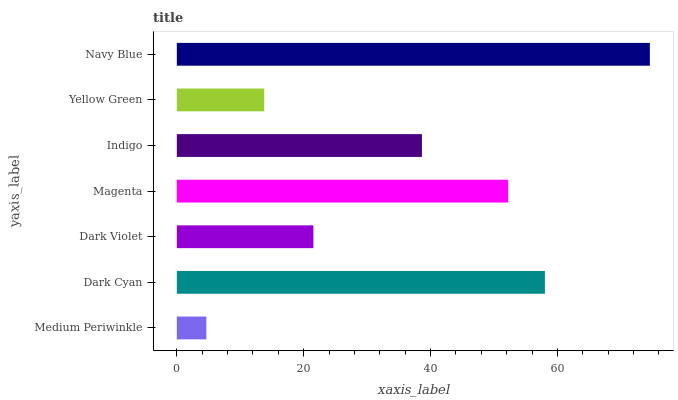Is Medium Periwinkle the minimum?
Answer yes or no. Yes. Is Navy Blue the maximum?
Answer yes or no. Yes. Is Dark Cyan the minimum?
Answer yes or no. No. Is Dark Cyan the maximum?
Answer yes or no. No. Is Dark Cyan greater than Medium Periwinkle?
Answer yes or no. Yes. Is Medium Periwinkle less than Dark Cyan?
Answer yes or no. Yes. Is Medium Periwinkle greater than Dark Cyan?
Answer yes or no. No. Is Dark Cyan less than Medium Periwinkle?
Answer yes or no. No. Is Indigo the high median?
Answer yes or no. Yes. Is Indigo the low median?
Answer yes or no. Yes. Is Navy Blue the high median?
Answer yes or no. No. Is Medium Periwinkle the low median?
Answer yes or no. No. 